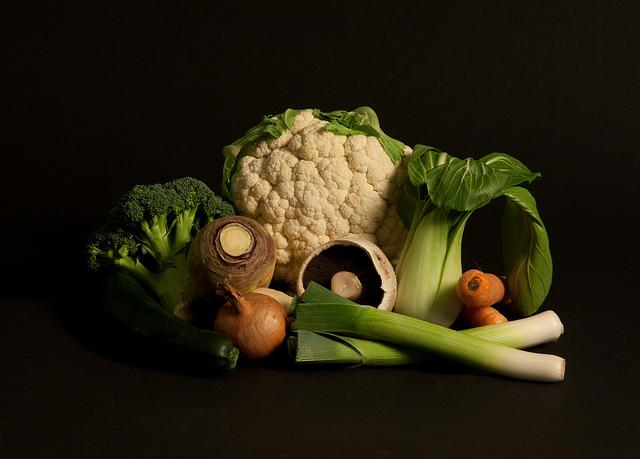Where can these foods be found? Please explain your reasoning. garden. The items are various vegetables that are grown in a garden. 